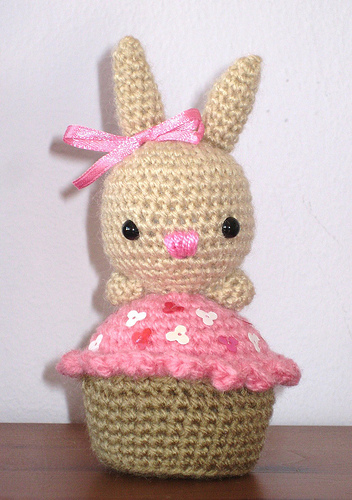<image>
Is the bow on the cupcake? No. The bow is not positioned on the cupcake. They may be near each other, but the bow is not supported by or resting on top of the cupcake. 